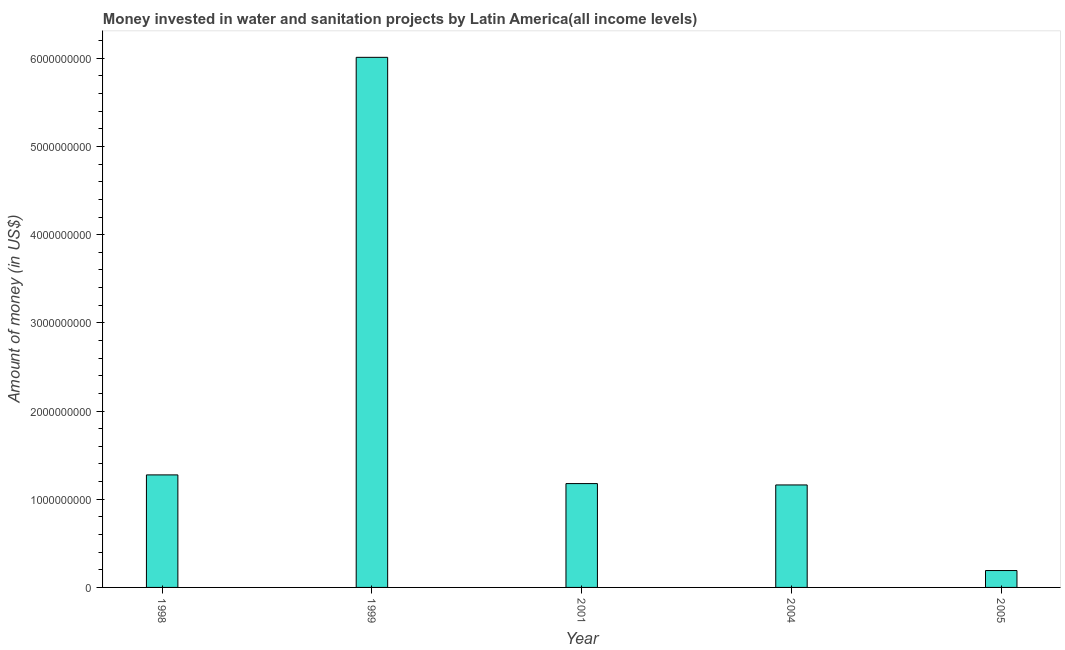What is the title of the graph?
Your answer should be very brief. Money invested in water and sanitation projects by Latin America(all income levels). What is the label or title of the X-axis?
Keep it short and to the point. Year. What is the label or title of the Y-axis?
Give a very brief answer. Amount of money (in US$). What is the investment in 2004?
Ensure brevity in your answer.  1.16e+09. Across all years, what is the maximum investment?
Provide a short and direct response. 6.01e+09. Across all years, what is the minimum investment?
Your answer should be very brief. 1.91e+08. In which year was the investment minimum?
Your answer should be compact. 2005. What is the sum of the investment?
Give a very brief answer. 9.82e+09. What is the difference between the investment in 2001 and 2005?
Provide a short and direct response. 9.86e+08. What is the average investment per year?
Ensure brevity in your answer.  1.96e+09. What is the median investment?
Ensure brevity in your answer.  1.18e+09. In how many years, is the investment greater than 1400000000 US$?
Offer a very short reply. 1. What is the ratio of the investment in 2001 to that in 2005?
Give a very brief answer. 6.15. Is the investment in 1998 less than that in 1999?
Make the answer very short. Yes. Is the difference between the investment in 1999 and 2001 greater than the difference between any two years?
Keep it short and to the point. No. What is the difference between the highest and the second highest investment?
Your response must be concise. 4.73e+09. Is the sum of the investment in 1998 and 1999 greater than the maximum investment across all years?
Make the answer very short. Yes. What is the difference between the highest and the lowest investment?
Make the answer very short. 5.82e+09. In how many years, is the investment greater than the average investment taken over all years?
Your answer should be compact. 1. How many bars are there?
Your answer should be compact. 5. How many years are there in the graph?
Your answer should be compact. 5. What is the difference between two consecutive major ticks on the Y-axis?
Give a very brief answer. 1.00e+09. Are the values on the major ticks of Y-axis written in scientific E-notation?
Your response must be concise. No. What is the Amount of money (in US$) of 1998?
Your response must be concise. 1.28e+09. What is the Amount of money (in US$) of 1999?
Make the answer very short. 6.01e+09. What is the Amount of money (in US$) of 2001?
Keep it short and to the point. 1.18e+09. What is the Amount of money (in US$) in 2004?
Give a very brief answer. 1.16e+09. What is the Amount of money (in US$) of 2005?
Make the answer very short. 1.91e+08. What is the difference between the Amount of money (in US$) in 1998 and 1999?
Provide a succinct answer. -4.73e+09. What is the difference between the Amount of money (in US$) in 1998 and 2001?
Give a very brief answer. 9.85e+07. What is the difference between the Amount of money (in US$) in 1998 and 2004?
Your answer should be compact. 1.14e+08. What is the difference between the Amount of money (in US$) in 1998 and 2005?
Make the answer very short. 1.08e+09. What is the difference between the Amount of money (in US$) in 1999 and 2001?
Keep it short and to the point. 4.83e+09. What is the difference between the Amount of money (in US$) in 1999 and 2004?
Ensure brevity in your answer.  4.85e+09. What is the difference between the Amount of money (in US$) in 1999 and 2005?
Ensure brevity in your answer.  5.82e+09. What is the difference between the Amount of money (in US$) in 2001 and 2004?
Make the answer very short. 1.54e+07. What is the difference between the Amount of money (in US$) in 2001 and 2005?
Offer a very short reply. 9.86e+08. What is the difference between the Amount of money (in US$) in 2004 and 2005?
Keep it short and to the point. 9.71e+08. What is the ratio of the Amount of money (in US$) in 1998 to that in 1999?
Provide a succinct answer. 0.21. What is the ratio of the Amount of money (in US$) in 1998 to that in 2001?
Offer a terse response. 1.08. What is the ratio of the Amount of money (in US$) in 1998 to that in 2004?
Your answer should be compact. 1.1. What is the ratio of the Amount of money (in US$) in 1998 to that in 2005?
Your answer should be very brief. 6.67. What is the ratio of the Amount of money (in US$) in 1999 to that in 2001?
Offer a terse response. 5.11. What is the ratio of the Amount of money (in US$) in 1999 to that in 2004?
Offer a terse response. 5.17. What is the ratio of the Amount of money (in US$) in 1999 to that in 2005?
Offer a very short reply. 31.4. What is the ratio of the Amount of money (in US$) in 2001 to that in 2005?
Offer a very short reply. 6.15. What is the ratio of the Amount of money (in US$) in 2004 to that in 2005?
Your answer should be compact. 6.07. 